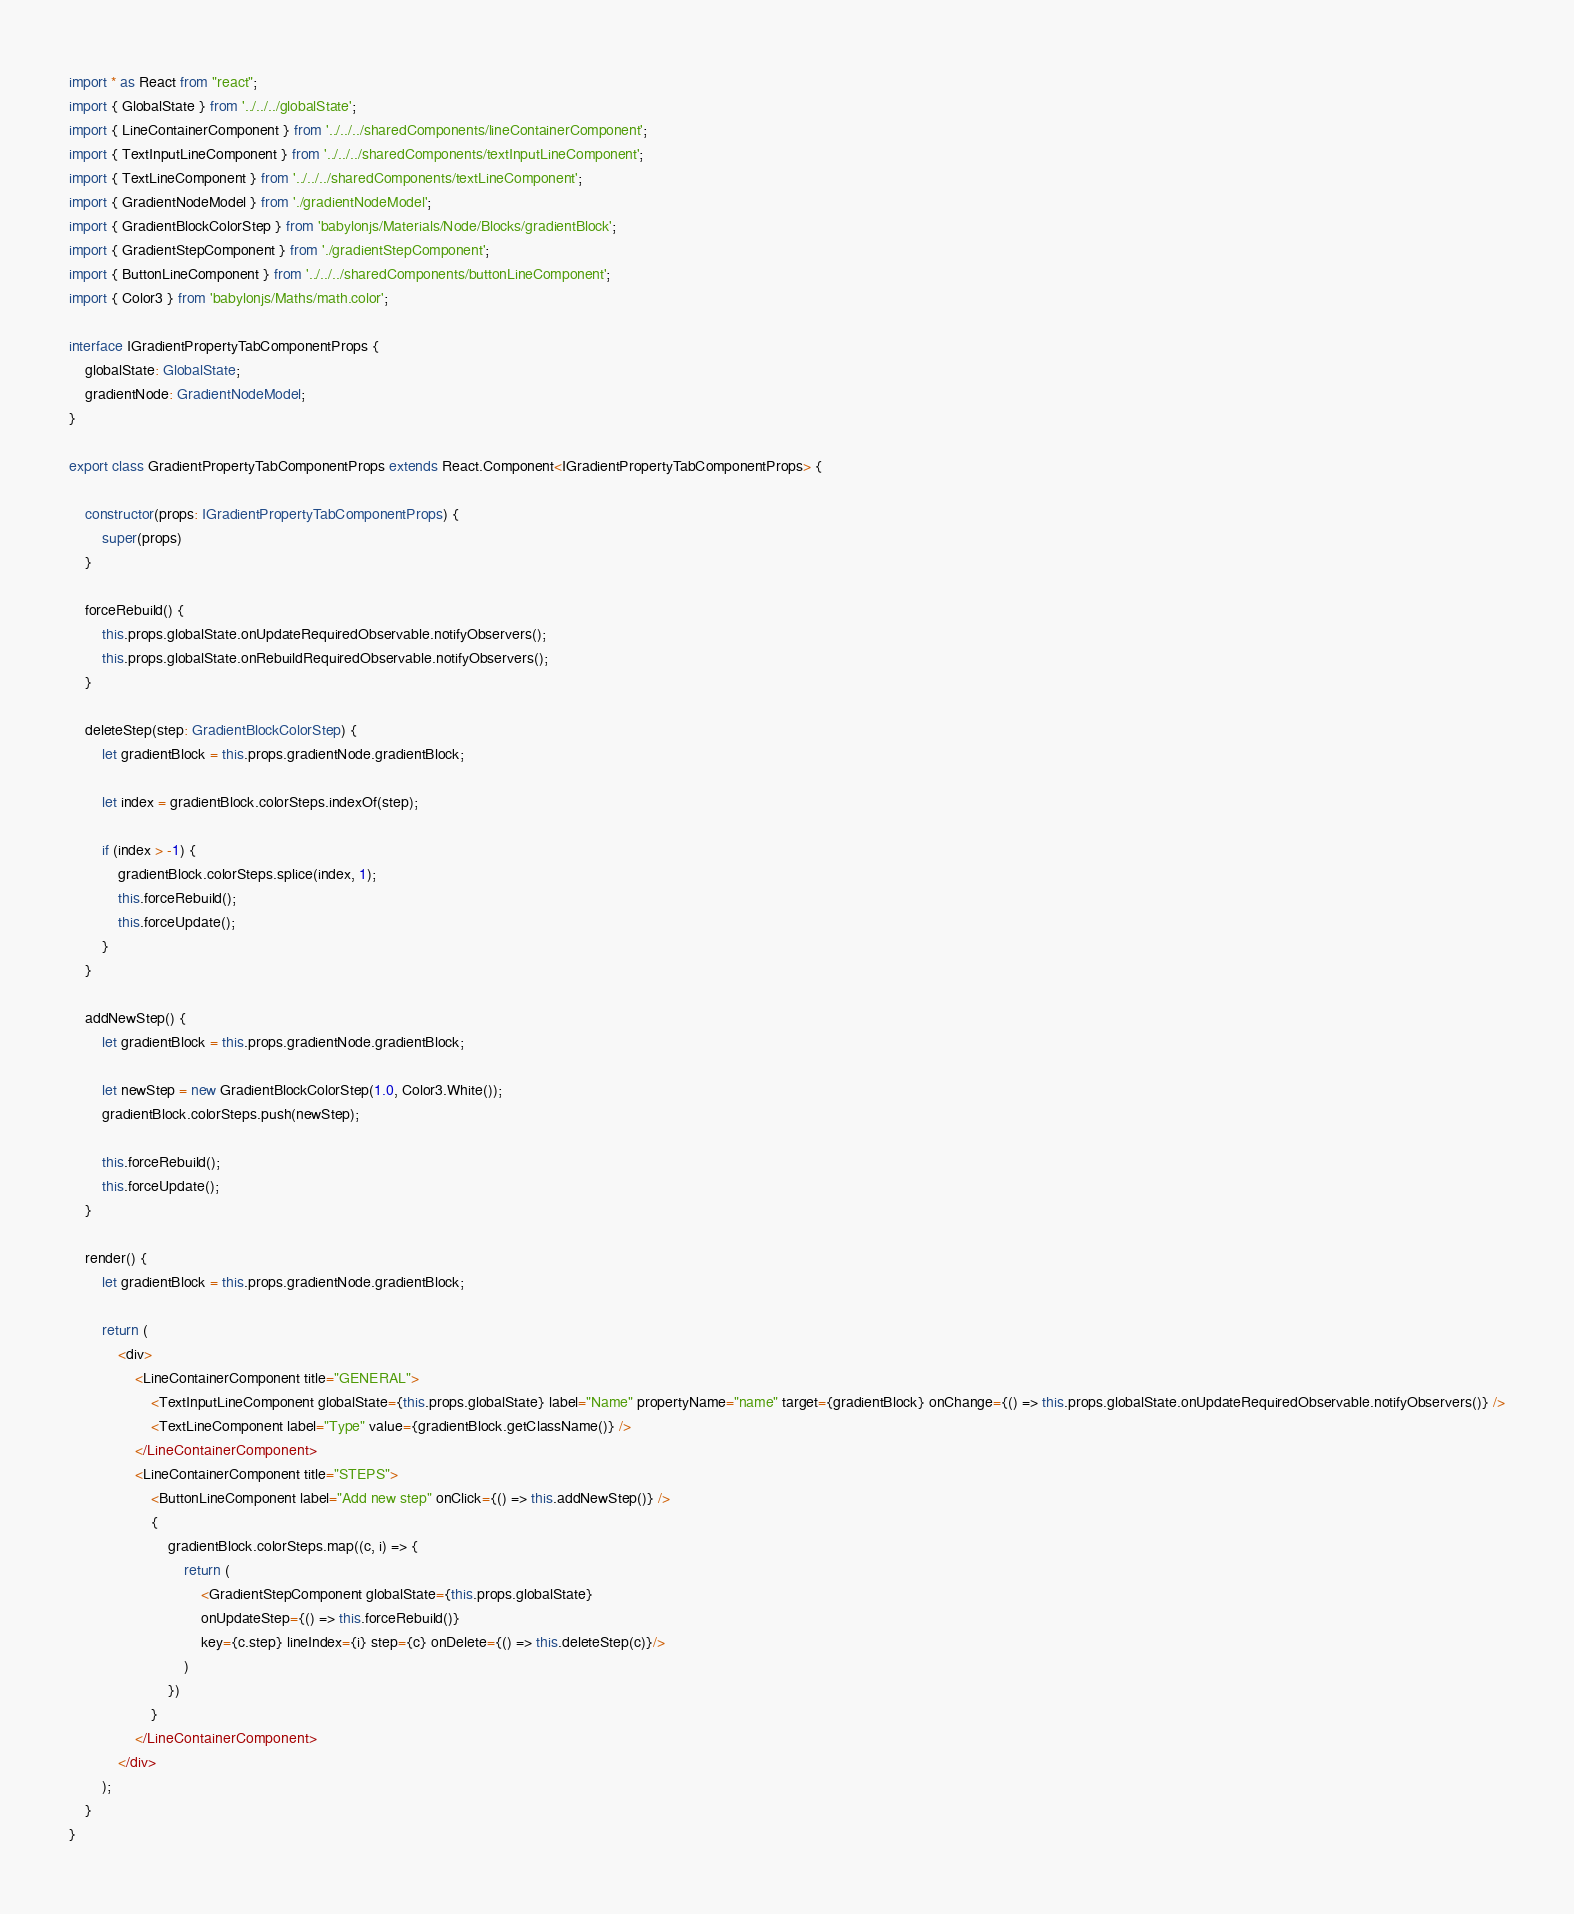Convert code to text. <code><loc_0><loc_0><loc_500><loc_500><_TypeScript_>
import * as React from "react";
import { GlobalState } from '../../../globalState';
import { LineContainerComponent } from '../../../sharedComponents/lineContainerComponent';
import { TextInputLineComponent } from '../../../sharedComponents/textInputLineComponent';
import { TextLineComponent } from '../../../sharedComponents/textLineComponent';
import { GradientNodeModel } from './gradientNodeModel';
import { GradientBlockColorStep } from 'babylonjs/Materials/Node/Blocks/gradientBlock';
import { GradientStepComponent } from './gradientStepComponent';
import { ButtonLineComponent } from '../../../sharedComponents/buttonLineComponent';
import { Color3 } from 'babylonjs/Maths/math.color';

interface IGradientPropertyTabComponentProps {
    globalState: GlobalState;
    gradientNode: GradientNodeModel;
}

export class GradientPropertyTabComponentProps extends React.Component<IGradientPropertyTabComponentProps> {

    constructor(props: IGradientPropertyTabComponentProps) {
        super(props)
    }

    forceRebuild() {
        this.props.globalState.onUpdateRequiredObservable.notifyObservers();
        this.props.globalState.onRebuildRequiredObservable.notifyObservers();
    }

    deleteStep(step: GradientBlockColorStep) {
        let gradientBlock = this.props.gradientNode.gradientBlock;

        let index = gradientBlock.colorSteps.indexOf(step);

        if (index > -1) {
            gradientBlock.colorSteps.splice(index, 1);
            this.forceRebuild();
            this.forceUpdate();
        }
    }

    addNewStep() {
        let gradientBlock = this.props.gradientNode.gradientBlock;

        let newStep = new GradientBlockColorStep(1.0, Color3.White());
        gradientBlock.colorSteps.push(newStep);

        this.forceRebuild();
        this.forceUpdate();
    }

    render() {
        let gradientBlock = this.props.gradientNode.gradientBlock;
      
        return (
            <div>
                <LineContainerComponent title="GENERAL">
                    <TextInputLineComponent globalState={this.props.globalState} label="Name" propertyName="name" target={gradientBlock} onChange={() => this.props.globalState.onUpdateRequiredObservable.notifyObservers()} />
                    <TextLineComponent label="Type" value={gradientBlock.getClassName()} />
                </LineContainerComponent>
                <LineContainerComponent title="STEPS">
                    <ButtonLineComponent label="Add new step" onClick={() => this.addNewStep()} />
                    {
                        gradientBlock.colorSteps.map((c, i) => {
                            return (
                                <GradientStepComponent globalState={this.props.globalState} 
                                onUpdateStep={() => this.forceRebuild()}
                                key={c.step} lineIndex={i} step={c} onDelete={() => this.deleteStep(c)}/>
                            )
                        })
                    }
                </LineContainerComponent>
            </div>
        );
    }
}</code> 